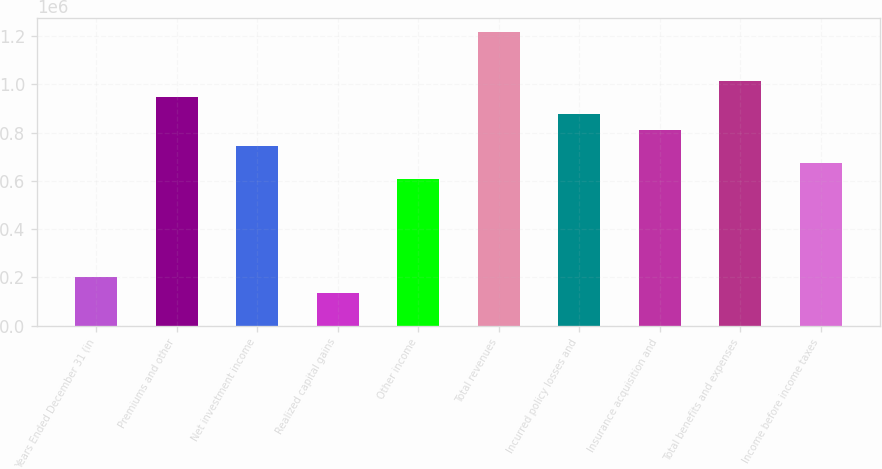<chart> <loc_0><loc_0><loc_500><loc_500><bar_chart><fcel>Years Ended December 31 (in<fcel>Premiums and other<fcel>Net investment income<fcel>Realized capital gains<fcel>Other income<fcel>Total revenues<fcel>Incurred policy losses and<fcel>Insurance acquisition and<fcel>Total benefits and expenses<fcel>Income before income taxes<nl><fcel>202681<fcel>945843<fcel>743162<fcel>135121<fcel>608042<fcel>1.21608e+06<fcel>878283<fcel>810722<fcel>1.0134e+06<fcel>675602<nl></chart> 